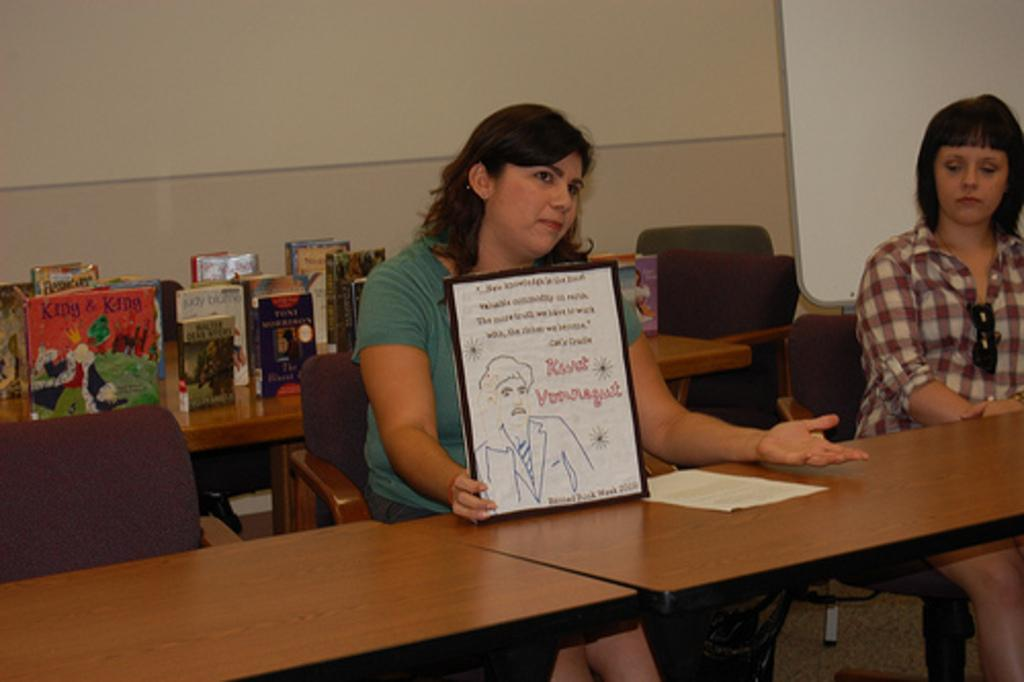What are the women in the image doing? The women in the image are sitting on chairs. Can you describe what one of the women is holding? One woman is holding a photo frame. What can be seen in the background of the image? There is a table in the background. What is placed on the table? Books are kept on the table. What type of potato is being judged by the women in the image? There is no potato or judging activity present in the image. How many mouths can be seen in the image? There is no mouth visible in the image; only women sitting on chairs, a photo frame, a table, and books are present. 